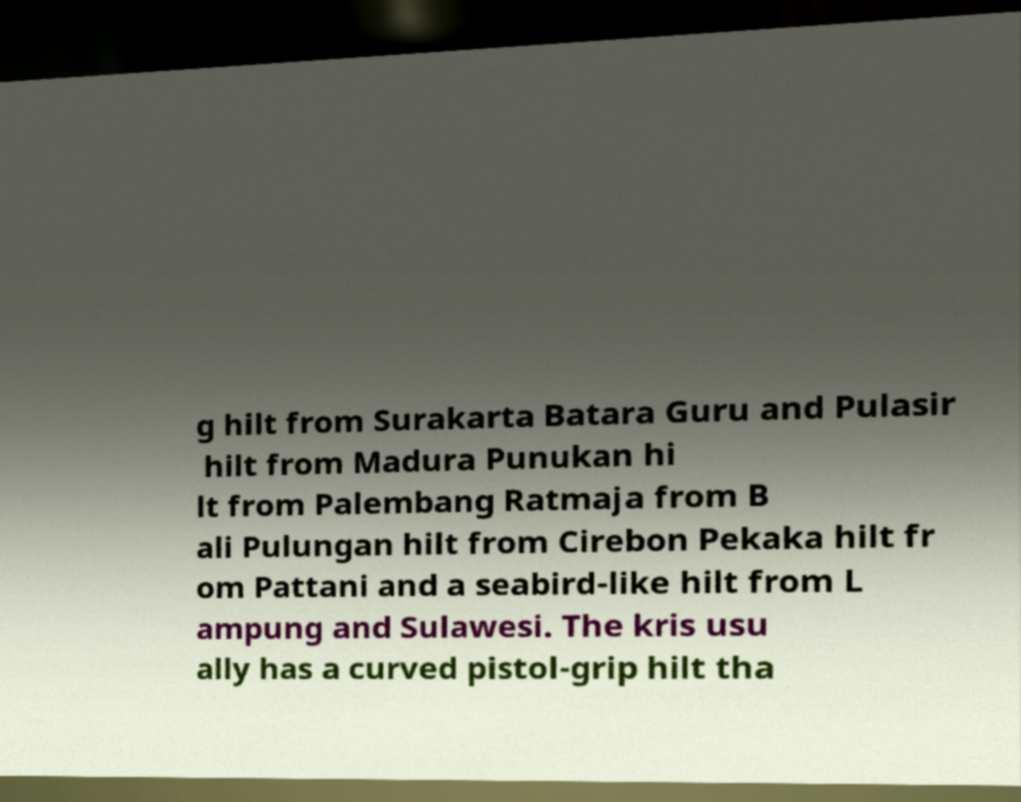For documentation purposes, I need the text within this image transcribed. Could you provide that? g hilt from Surakarta Batara Guru and Pulasir hilt from Madura Punukan hi lt from Palembang Ratmaja from B ali Pulungan hilt from Cirebon Pekaka hilt fr om Pattani and a seabird-like hilt from L ampung and Sulawesi. The kris usu ally has a curved pistol-grip hilt tha 